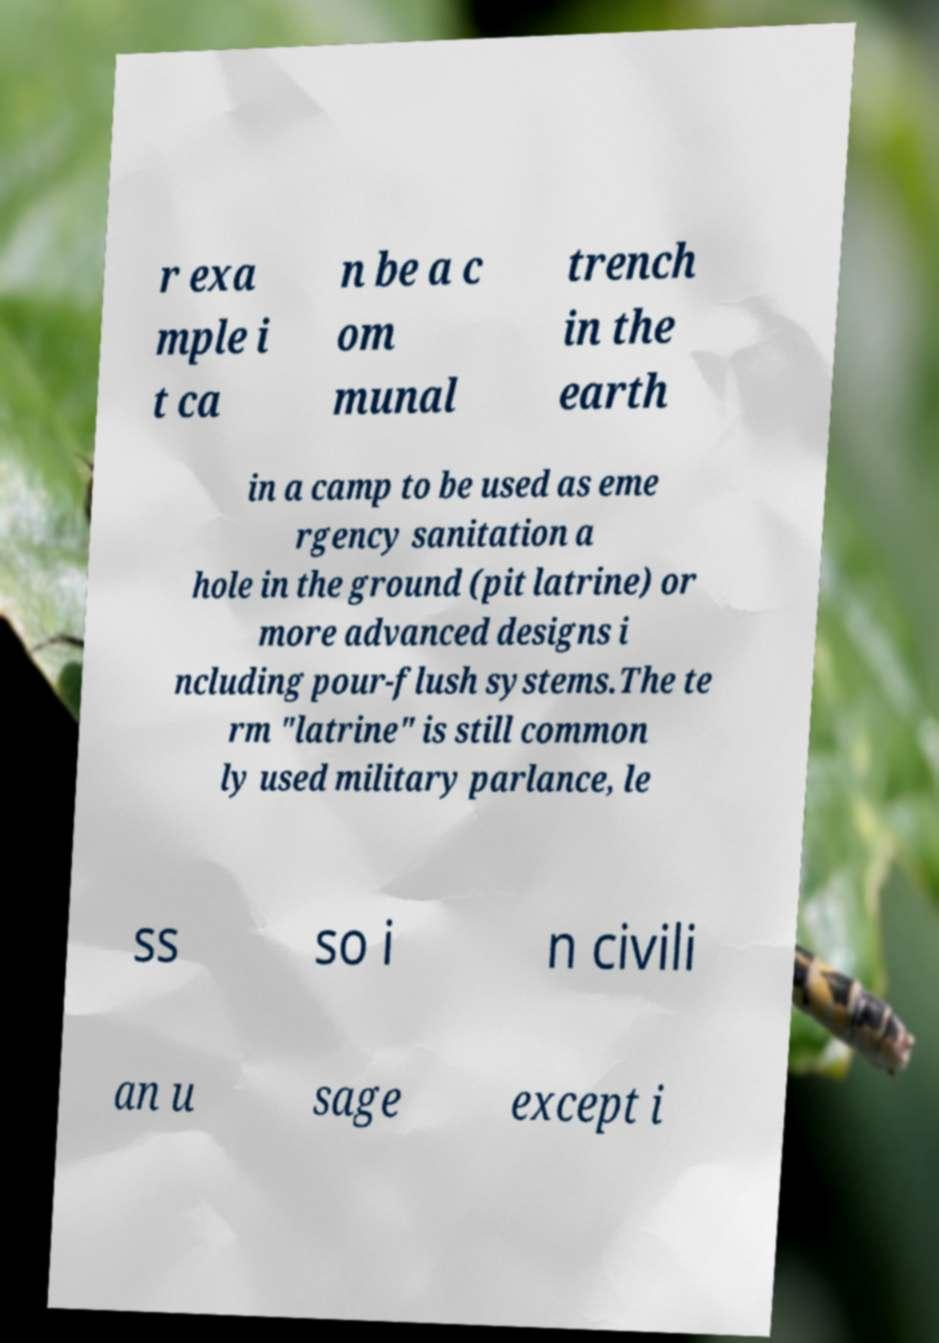Could you assist in decoding the text presented in this image and type it out clearly? r exa mple i t ca n be a c om munal trench in the earth in a camp to be used as eme rgency sanitation a hole in the ground (pit latrine) or more advanced designs i ncluding pour-flush systems.The te rm "latrine" is still common ly used military parlance, le ss so i n civili an u sage except i 